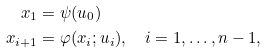<formula> <loc_0><loc_0><loc_500><loc_500>x _ { 1 } & = \psi ( u _ { 0 } ) \\ x _ { i + 1 } & = \varphi ( x _ { i } ; u _ { i } ) , \quad i = 1 , \dots , n - 1 ,</formula> 